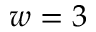<formula> <loc_0><loc_0><loc_500><loc_500>w = 3</formula> 